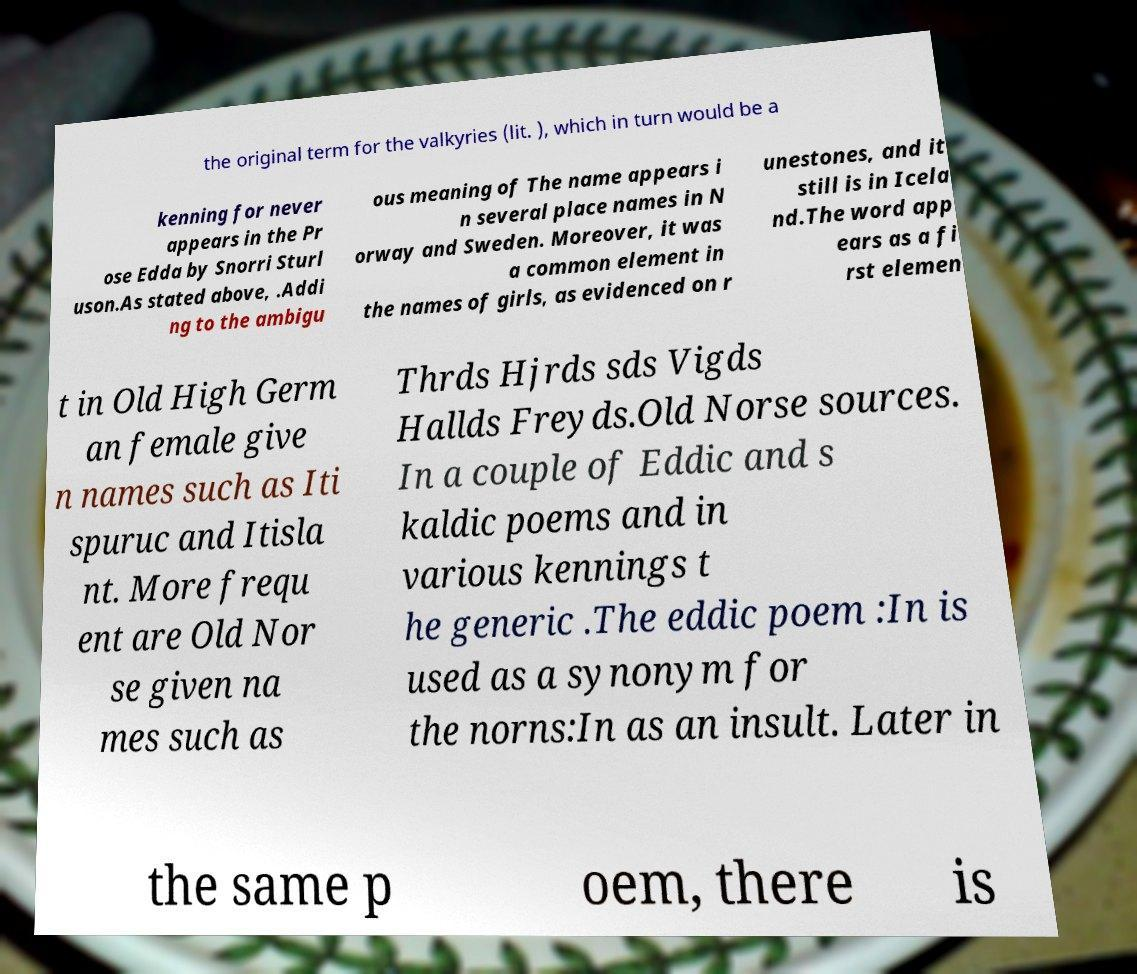Could you extract and type out the text from this image? the original term for the valkyries (lit. ), which in turn would be a kenning for never appears in the Pr ose Edda by Snorri Sturl uson.As stated above, .Addi ng to the ambigu ous meaning of The name appears i n several place names in N orway and Sweden. Moreover, it was a common element in the names of girls, as evidenced on r unestones, and it still is in Icela nd.The word app ears as a fi rst elemen t in Old High Germ an female give n names such as Iti spuruc and Itisla nt. More frequ ent are Old Nor se given na mes such as Thrds Hjrds sds Vigds Hallds Freyds.Old Norse sources. In a couple of Eddic and s kaldic poems and in various kennings t he generic .The eddic poem :In is used as a synonym for the norns:In as an insult. Later in the same p oem, there is 